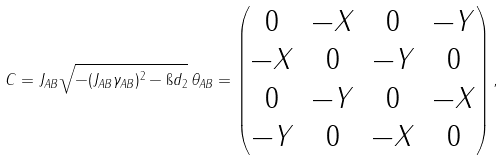<formula> <loc_0><loc_0><loc_500><loc_500>C = J _ { A B } \sqrt { - ( J _ { A B } \gamma _ { A B } ) ^ { 2 } - \i d _ { 2 } } \, \theta _ { A B } = \begin{pmatrix} 0 & - X & 0 & - Y \\ - X & 0 & - Y & 0 \\ 0 & - Y & 0 & - X \\ - Y & 0 & - X & 0 \\ \end{pmatrix} ,</formula> 